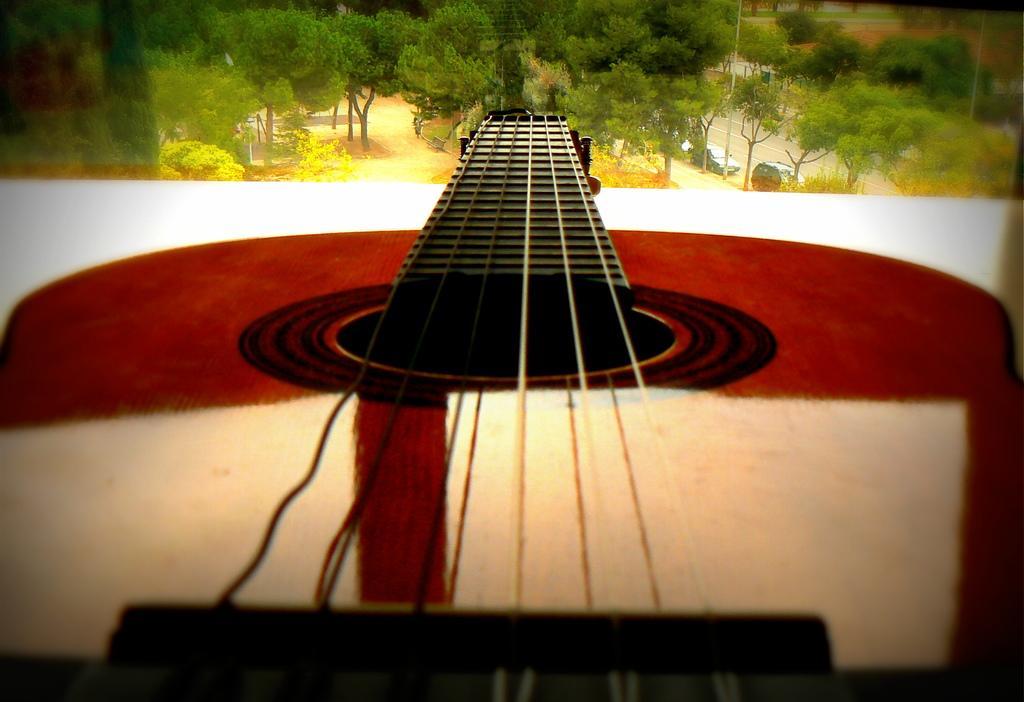Can you describe this image briefly? In this picture there is a guitar which is placed on the table. At the top I can see many trees, plants, grass, road and pole. Beside the road I can see some cars were parked. 